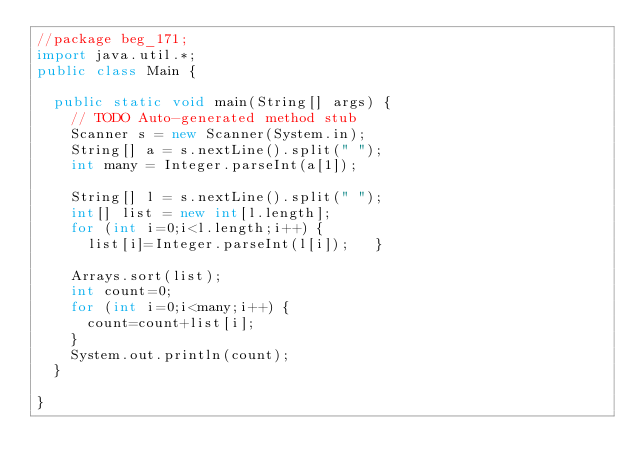Convert code to text. <code><loc_0><loc_0><loc_500><loc_500><_Java_>//package beg_171;
import java.util.*;
public class Main {

	public static void main(String[] args) {
		// TODO Auto-generated method stub
		Scanner s = new Scanner(System.in);
		String[] a = s.nextLine().split(" ");
		int many = Integer.parseInt(a[1]);
		
		String[] l = s.nextLine().split(" ");
		int[] list = new int[l.length];
		for (int i=0;i<l.length;i++) {
			list[i]=Integer.parseInt(l[i]);		}
		
		Arrays.sort(list);
		int count=0;
		for (int i=0;i<many;i++) {
			count=count+list[i];
		}
		System.out.println(count);
	}

}
</code> 